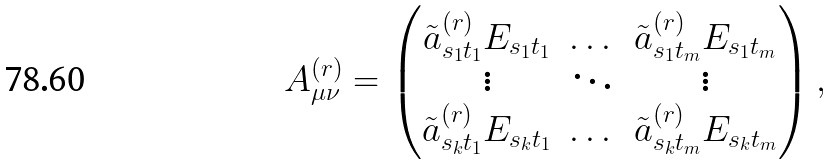<formula> <loc_0><loc_0><loc_500><loc_500>A _ { \mu \nu } ^ { ( r ) } = \begin{pmatrix} \tilde { a } ^ { ( r ) } _ { s _ { 1 } t _ { 1 } } E _ { s _ { 1 } t _ { 1 } } & \dots & \tilde { a } ^ { ( r ) } _ { s _ { 1 } t _ { m } } E _ { s _ { 1 } t _ { m } } \\ \vdots & \ddots & \vdots \\ \tilde { a } ^ { ( r ) } _ { s _ { k } t _ { 1 } } E _ { s _ { k } t _ { 1 } } & \dots & \tilde { a } ^ { ( r ) } _ { s _ { k } t _ { m } } E _ { s _ { k } t _ { m } } \end{pmatrix} ,</formula> 